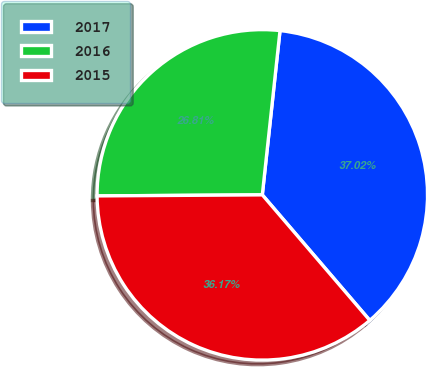<chart> <loc_0><loc_0><loc_500><loc_500><pie_chart><fcel>2017<fcel>2016<fcel>2015<nl><fcel>37.02%<fcel>26.81%<fcel>36.17%<nl></chart> 